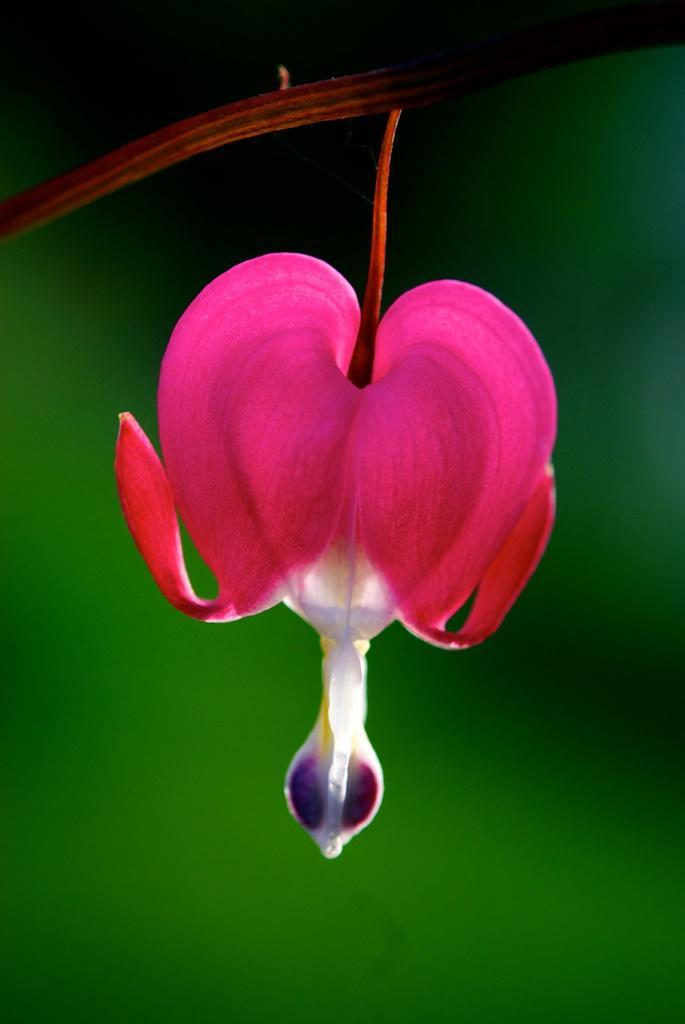Describe this image in one or two sentences. In this picture we can see a flower to the branch. Behind the flower there is the blurred background. 